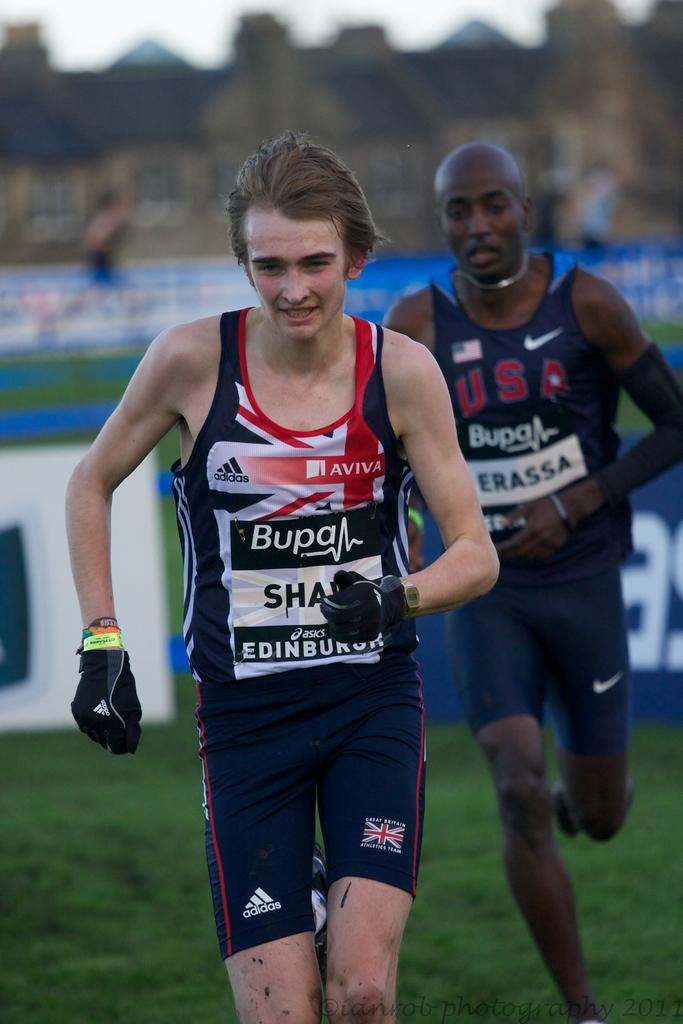Provide a one-sentence caption for the provided image. A man wears a shirt with the Adiddas and Aviva logos. 